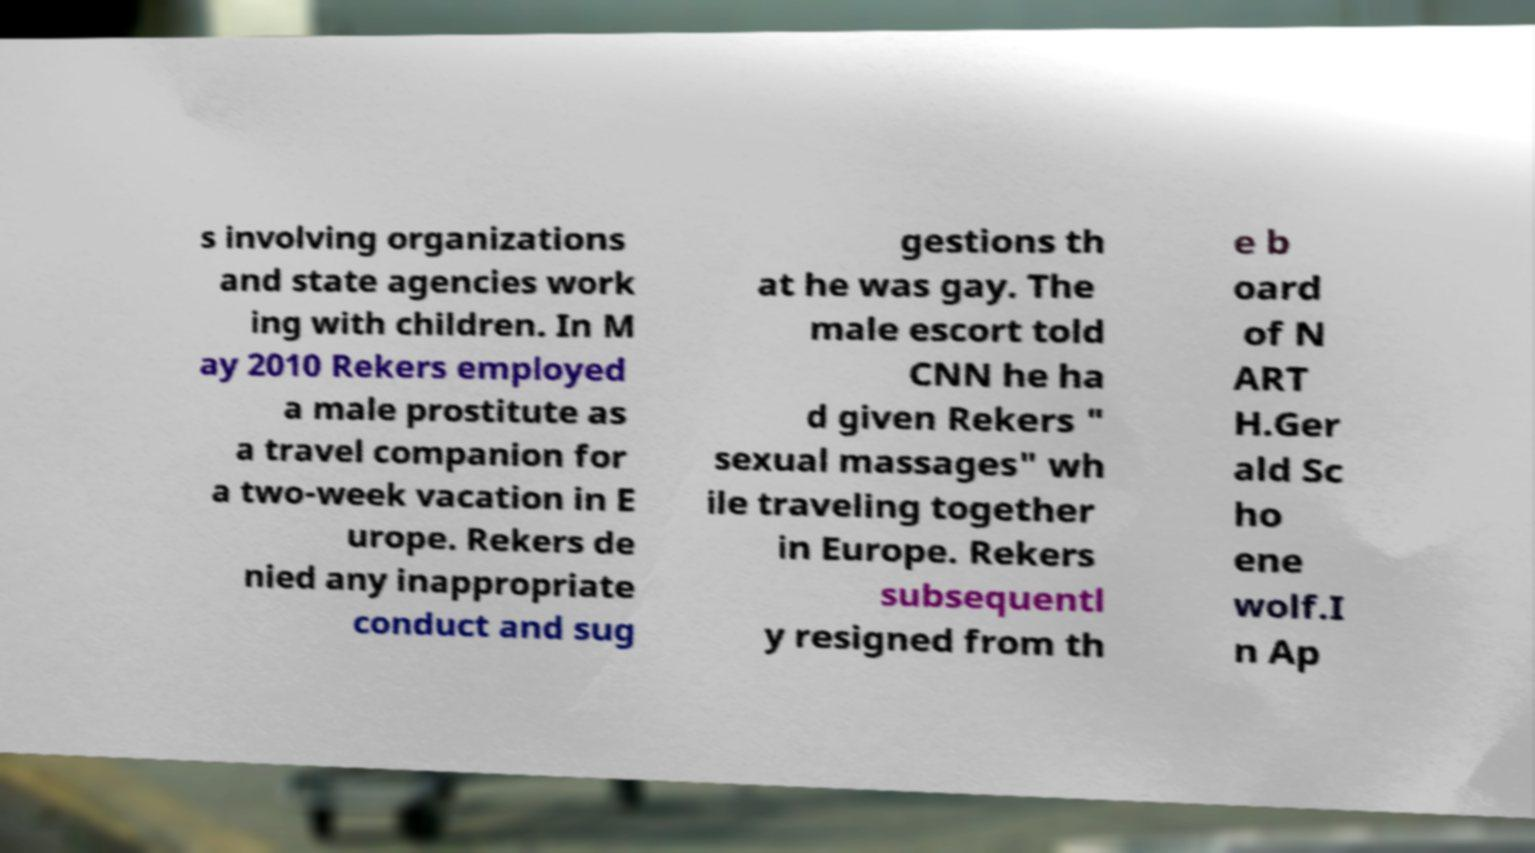I need the written content from this picture converted into text. Can you do that? s involving organizations and state agencies work ing with children. In M ay 2010 Rekers employed a male prostitute as a travel companion for a two-week vacation in E urope. Rekers de nied any inappropriate conduct and sug gestions th at he was gay. The male escort told CNN he ha d given Rekers " sexual massages" wh ile traveling together in Europe. Rekers subsequentl y resigned from th e b oard of N ART H.Ger ald Sc ho ene wolf.I n Ap 